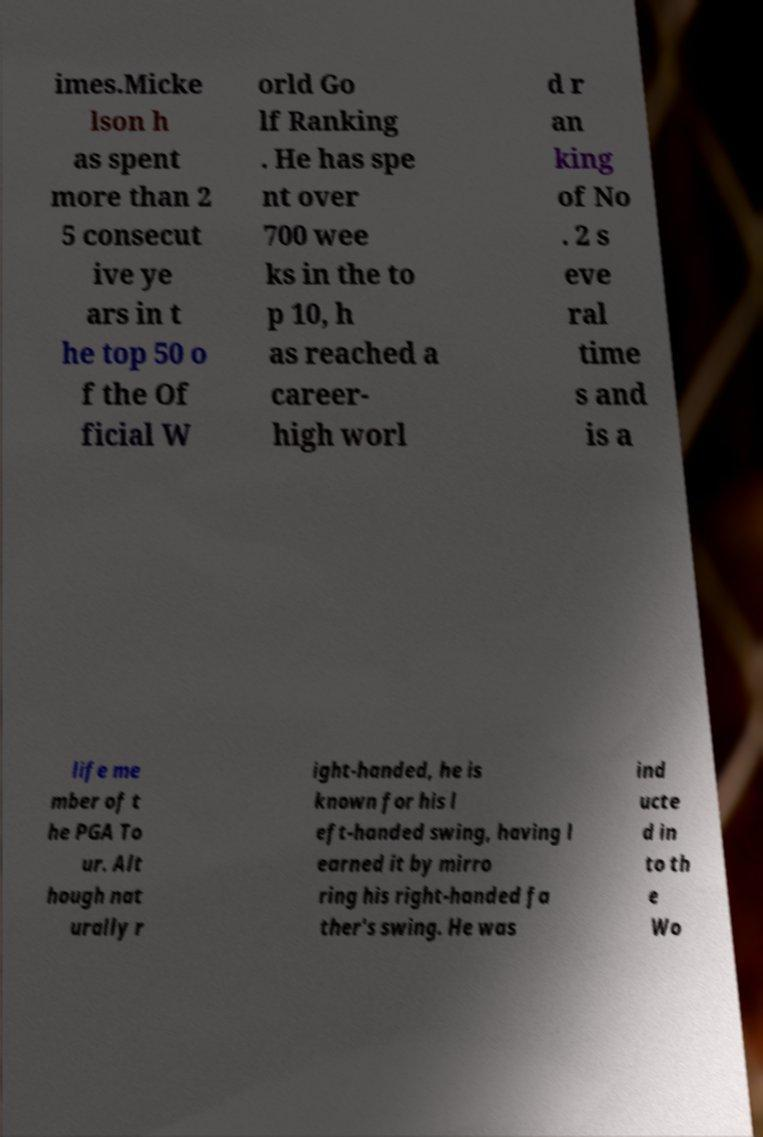What messages or text are displayed in this image? I need them in a readable, typed format. imes.Micke lson h as spent more than 2 5 consecut ive ye ars in t he top 50 o f the Of ficial W orld Go lf Ranking . He has spe nt over 700 wee ks in the to p 10, h as reached a career- high worl d r an king of No . 2 s eve ral time s and is a life me mber of t he PGA To ur. Alt hough nat urally r ight-handed, he is known for his l eft-handed swing, having l earned it by mirro ring his right-handed fa ther's swing. He was ind ucte d in to th e Wo 